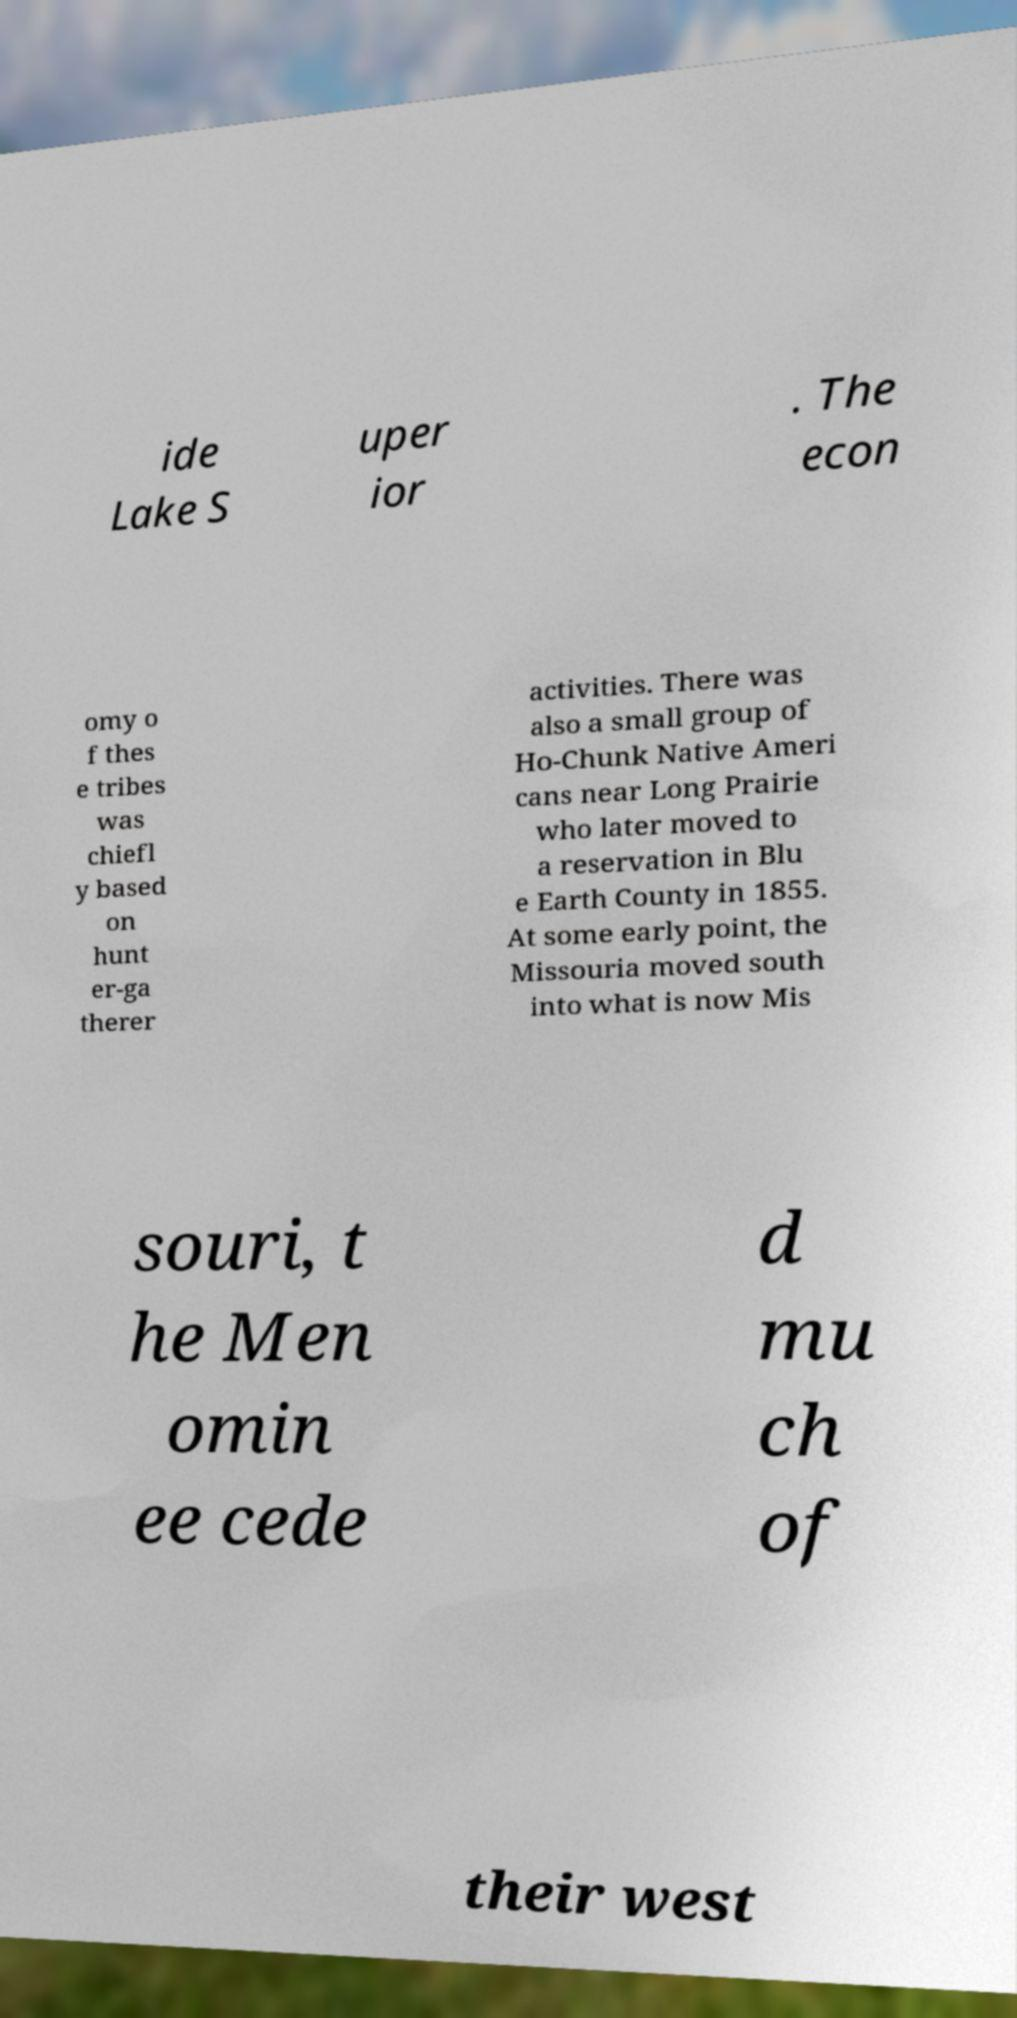What messages or text are displayed in this image? I need them in a readable, typed format. ide Lake S uper ior . The econ omy o f thes e tribes was chiefl y based on hunt er-ga therer activities. There was also a small group of Ho-Chunk Native Ameri cans near Long Prairie who later moved to a reservation in Blu e Earth County in 1855. At some early point, the Missouria moved south into what is now Mis souri, t he Men omin ee cede d mu ch of their west 